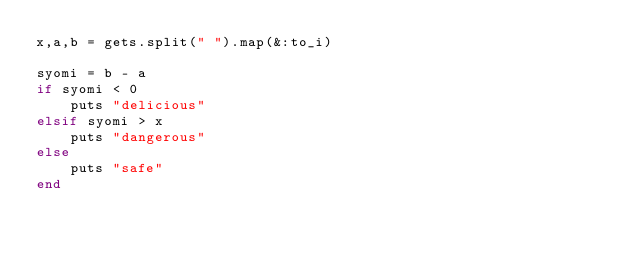Convert code to text. <code><loc_0><loc_0><loc_500><loc_500><_Ruby_>x,a,b = gets.split(" ").map(&:to_i)

syomi = b - a
if syomi < 0
    puts "delicious"
elsif syomi > x
    puts "dangerous"
else 
    puts "safe"
end
    </code> 